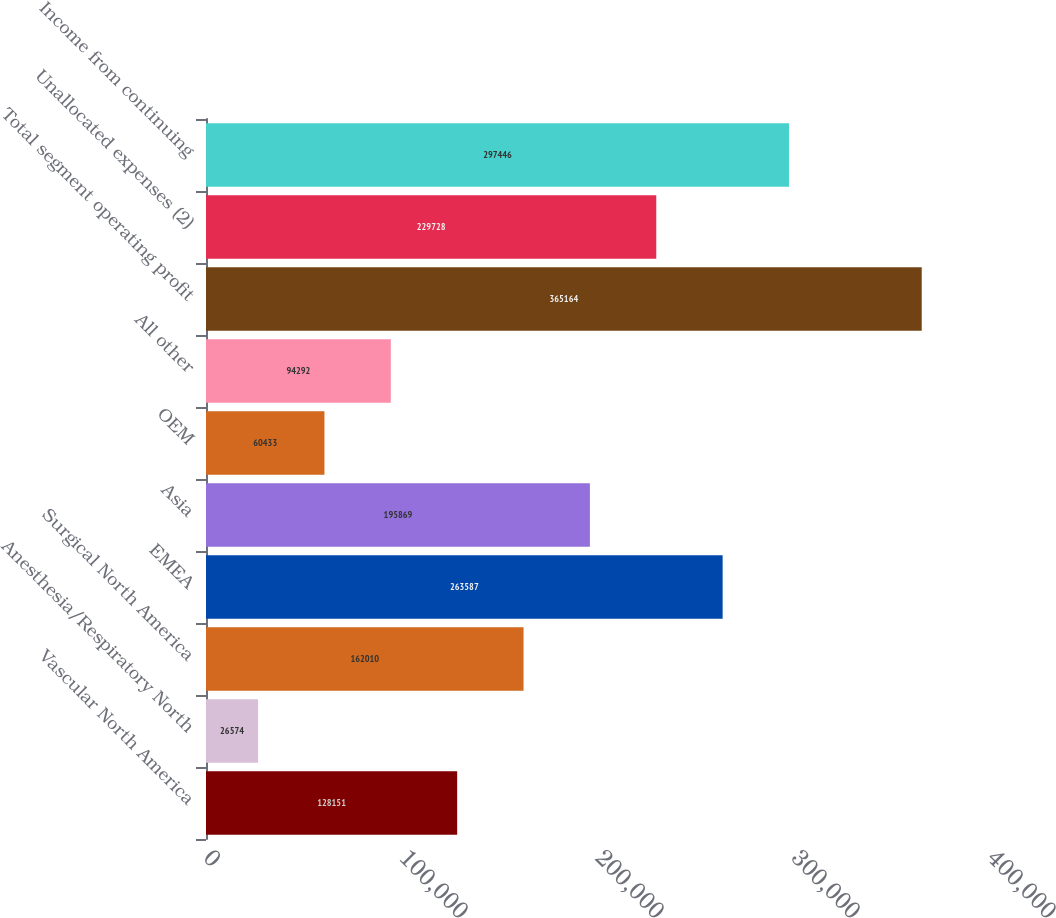Convert chart. <chart><loc_0><loc_0><loc_500><loc_500><bar_chart><fcel>Vascular North America<fcel>Anesthesia/Respiratory North<fcel>Surgical North America<fcel>EMEA<fcel>Asia<fcel>OEM<fcel>All other<fcel>Total segment operating profit<fcel>Unallocated expenses (2)<fcel>Income from continuing<nl><fcel>128151<fcel>26574<fcel>162010<fcel>263587<fcel>195869<fcel>60433<fcel>94292<fcel>365164<fcel>229728<fcel>297446<nl></chart> 